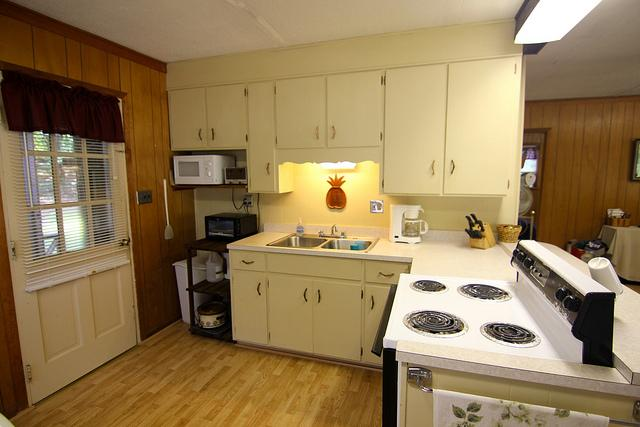How is the kitchen counter by the stove illuminated?

Choices:
A) led light
B) incandescent light
C) halogen light
D) fluorescent light fluorescent light 